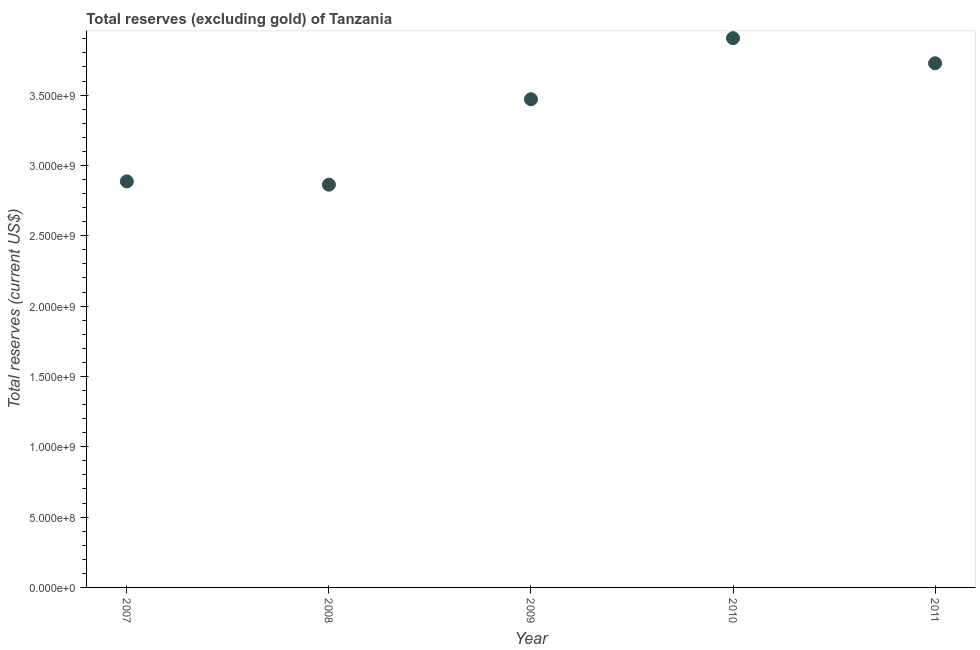What is the total reserves (excluding gold) in 2007?
Your response must be concise. 2.89e+09. Across all years, what is the maximum total reserves (excluding gold)?
Ensure brevity in your answer.  3.90e+09. Across all years, what is the minimum total reserves (excluding gold)?
Your answer should be very brief. 2.86e+09. In which year was the total reserves (excluding gold) maximum?
Provide a succinct answer. 2010. What is the sum of the total reserves (excluding gold)?
Your response must be concise. 1.69e+1. What is the difference between the total reserves (excluding gold) in 2010 and 2011?
Ensure brevity in your answer.  1.79e+08. What is the average total reserves (excluding gold) per year?
Offer a very short reply. 3.37e+09. What is the median total reserves (excluding gold)?
Keep it short and to the point. 3.47e+09. Do a majority of the years between 2009 and 2011 (inclusive) have total reserves (excluding gold) greater than 1900000000 US$?
Give a very brief answer. Yes. What is the ratio of the total reserves (excluding gold) in 2008 to that in 2009?
Keep it short and to the point. 0.82. Is the total reserves (excluding gold) in 2007 less than that in 2010?
Ensure brevity in your answer.  Yes. What is the difference between the highest and the second highest total reserves (excluding gold)?
Make the answer very short. 1.79e+08. Is the sum of the total reserves (excluding gold) in 2010 and 2011 greater than the maximum total reserves (excluding gold) across all years?
Your answer should be compact. Yes. What is the difference between the highest and the lowest total reserves (excluding gold)?
Keep it short and to the point. 1.04e+09. What is the difference between two consecutive major ticks on the Y-axis?
Your response must be concise. 5.00e+08. Does the graph contain any zero values?
Offer a very short reply. No. Does the graph contain grids?
Keep it short and to the point. No. What is the title of the graph?
Make the answer very short. Total reserves (excluding gold) of Tanzania. What is the label or title of the X-axis?
Keep it short and to the point. Year. What is the label or title of the Y-axis?
Make the answer very short. Total reserves (current US$). What is the Total reserves (current US$) in 2007?
Keep it short and to the point. 2.89e+09. What is the Total reserves (current US$) in 2008?
Keep it short and to the point. 2.86e+09. What is the Total reserves (current US$) in 2009?
Offer a terse response. 3.47e+09. What is the Total reserves (current US$) in 2010?
Provide a short and direct response. 3.90e+09. What is the Total reserves (current US$) in 2011?
Ensure brevity in your answer.  3.73e+09. What is the difference between the Total reserves (current US$) in 2007 and 2008?
Offer a terse response. 2.35e+07. What is the difference between the Total reserves (current US$) in 2007 and 2009?
Your answer should be very brief. -5.84e+08. What is the difference between the Total reserves (current US$) in 2007 and 2010?
Offer a terse response. -1.02e+09. What is the difference between the Total reserves (current US$) in 2007 and 2011?
Your answer should be compact. -8.40e+08. What is the difference between the Total reserves (current US$) in 2008 and 2009?
Your answer should be very brief. -6.08e+08. What is the difference between the Total reserves (current US$) in 2008 and 2010?
Your response must be concise. -1.04e+09. What is the difference between the Total reserves (current US$) in 2008 and 2011?
Keep it short and to the point. -8.63e+08. What is the difference between the Total reserves (current US$) in 2009 and 2010?
Make the answer very short. -4.34e+08. What is the difference between the Total reserves (current US$) in 2009 and 2011?
Your answer should be very brief. -2.56e+08. What is the difference between the Total reserves (current US$) in 2010 and 2011?
Your response must be concise. 1.79e+08. What is the ratio of the Total reserves (current US$) in 2007 to that in 2009?
Make the answer very short. 0.83. What is the ratio of the Total reserves (current US$) in 2007 to that in 2010?
Make the answer very short. 0.74. What is the ratio of the Total reserves (current US$) in 2007 to that in 2011?
Make the answer very short. 0.78. What is the ratio of the Total reserves (current US$) in 2008 to that in 2009?
Your answer should be compact. 0.82. What is the ratio of the Total reserves (current US$) in 2008 to that in 2010?
Provide a short and direct response. 0.73. What is the ratio of the Total reserves (current US$) in 2008 to that in 2011?
Your answer should be very brief. 0.77. What is the ratio of the Total reserves (current US$) in 2009 to that in 2010?
Your answer should be very brief. 0.89. What is the ratio of the Total reserves (current US$) in 2009 to that in 2011?
Give a very brief answer. 0.93. What is the ratio of the Total reserves (current US$) in 2010 to that in 2011?
Provide a succinct answer. 1.05. 